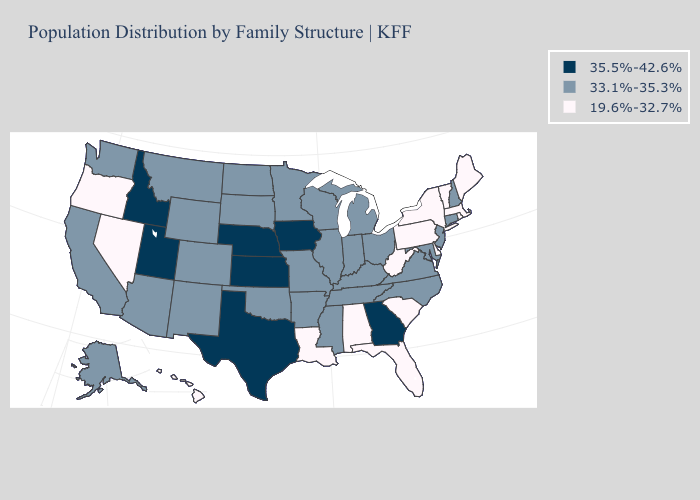What is the value of Rhode Island?
Keep it brief. 19.6%-32.7%. What is the value of Minnesota?
Keep it brief. 33.1%-35.3%. Name the states that have a value in the range 33.1%-35.3%?
Write a very short answer. Alaska, Arizona, Arkansas, California, Colorado, Connecticut, Illinois, Indiana, Kentucky, Maryland, Michigan, Minnesota, Mississippi, Missouri, Montana, New Hampshire, New Jersey, New Mexico, North Carolina, North Dakota, Ohio, Oklahoma, South Dakota, Tennessee, Virginia, Washington, Wisconsin, Wyoming. What is the value of North Dakota?
Short answer required. 33.1%-35.3%. What is the lowest value in the West?
Short answer required. 19.6%-32.7%. What is the value of Vermont?
Keep it brief. 19.6%-32.7%. Name the states that have a value in the range 33.1%-35.3%?
Concise answer only. Alaska, Arizona, Arkansas, California, Colorado, Connecticut, Illinois, Indiana, Kentucky, Maryland, Michigan, Minnesota, Mississippi, Missouri, Montana, New Hampshire, New Jersey, New Mexico, North Carolina, North Dakota, Ohio, Oklahoma, South Dakota, Tennessee, Virginia, Washington, Wisconsin, Wyoming. Name the states that have a value in the range 33.1%-35.3%?
Be succinct. Alaska, Arizona, Arkansas, California, Colorado, Connecticut, Illinois, Indiana, Kentucky, Maryland, Michigan, Minnesota, Mississippi, Missouri, Montana, New Hampshire, New Jersey, New Mexico, North Carolina, North Dakota, Ohio, Oklahoma, South Dakota, Tennessee, Virginia, Washington, Wisconsin, Wyoming. Does the map have missing data?
Quick response, please. No. Name the states that have a value in the range 19.6%-32.7%?
Concise answer only. Alabama, Delaware, Florida, Hawaii, Louisiana, Maine, Massachusetts, Nevada, New York, Oregon, Pennsylvania, Rhode Island, South Carolina, Vermont, West Virginia. What is the value of California?
Give a very brief answer. 33.1%-35.3%. Which states have the lowest value in the USA?
Be succinct. Alabama, Delaware, Florida, Hawaii, Louisiana, Maine, Massachusetts, Nevada, New York, Oregon, Pennsylvania, Rhode Island, South Carolina, Vermont, West Virginia. What is the lowest value in the USA?
Keep it brief. 19.6%-32.7%. 